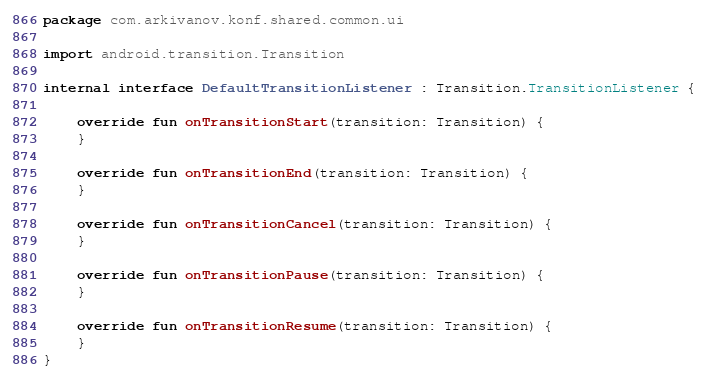<code> <loc_0><loc_0><loc_500><loc_500><_Kotlin_>package com.arkivanov.konf.shared.common.ui

import android.transition.Transition

internal interface DefaultTransitionListener : Transition.TransitionListener {

    override fun onTransitionStart(transition: Transition) {
    }

    override fun onTransitionEnd(transition: Transition) {
    }

    override fun onTransitionCancel(transition: Transition) {
    }

    override fun onTransitionPause(transition: Transition) {
    }

    override fun onTransitionResume(transition: Transition) {
    }
}
</code> 